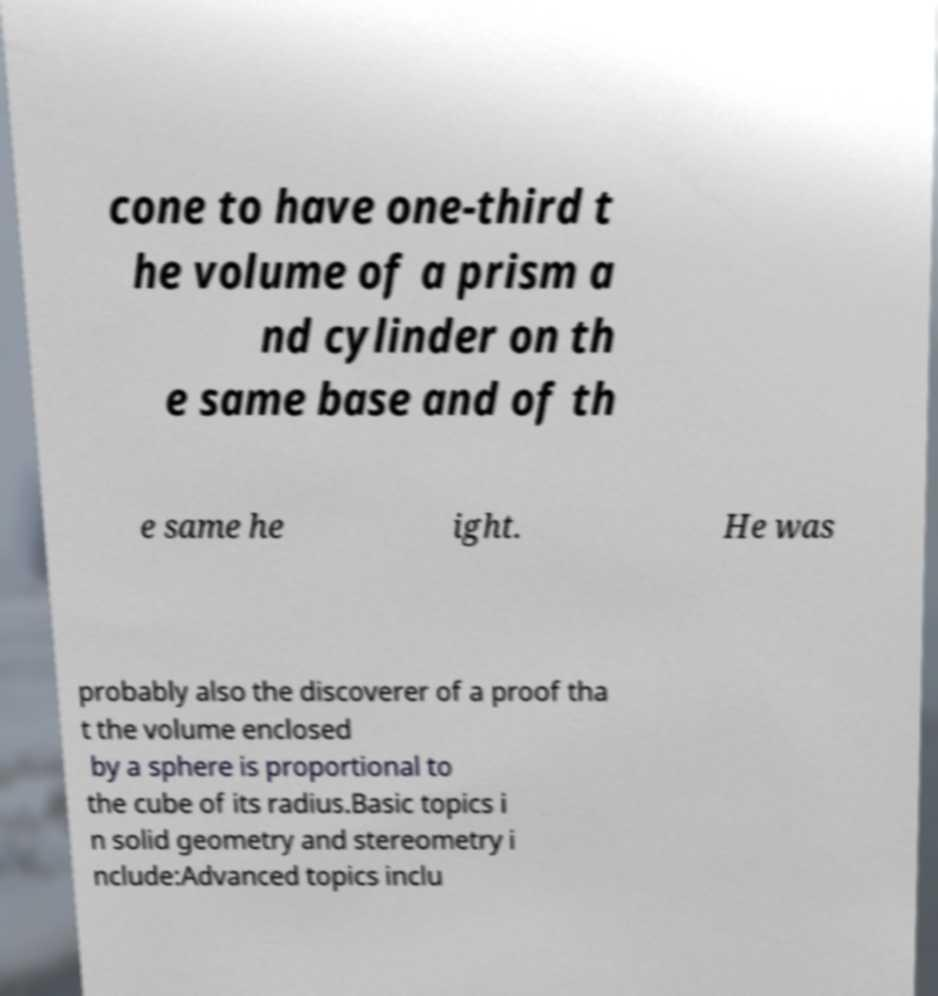Can you accurately transcribe the text from the provided image for me? cone to have one-third t he volume of a prism a nd cylinder on th e same base and of th e same he ight. He was probably also the discoverer of a proof tha t the volume enclosed by a sphere is proportional to the cube of its radius.Basic topics i n solid geometry and stereometry i nclude:Advanced topics inclu 